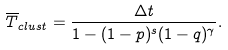<formula> <loc_0><loc_0><loc_500><loc_500>\overline { T } _ { c l u s t } = \frac { \Delta t } { 1 - ( 1 - p ) ^ { s } ( 1 - q ) ^ { \gamma } } .</formula> 